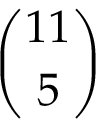Convert formula to latex. <formula><loc_0><loc_0><loc_500><loc_500>\binom { 1 1 } { 5 }</formula> 